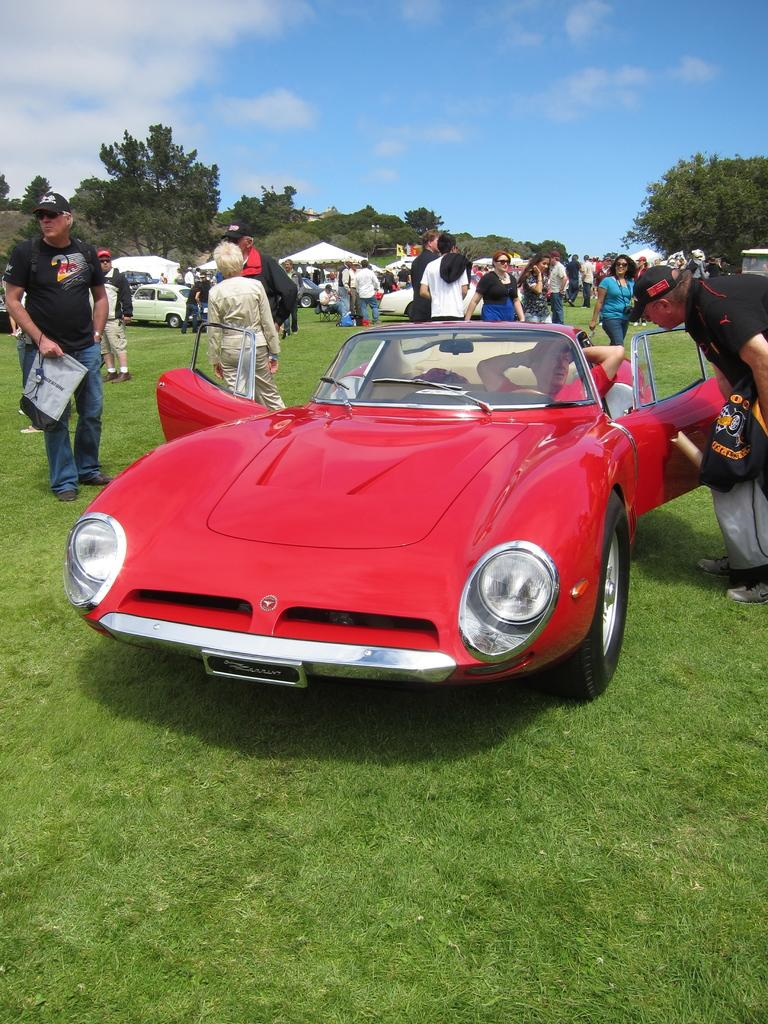What is the main subject of the image? There is a car in the image. Are there any living beings in the image? Yes, there are humans in the image. What type of natural elements can be seen in the image? Trees and mountains are present in the image. What type of berry is being picked by the humans in the image? There is no berry or berry-picking activity depicted in the image. How many hands can be seen in the image? The number of hands cannot be determined from the image, as it only shows a car and humans. 